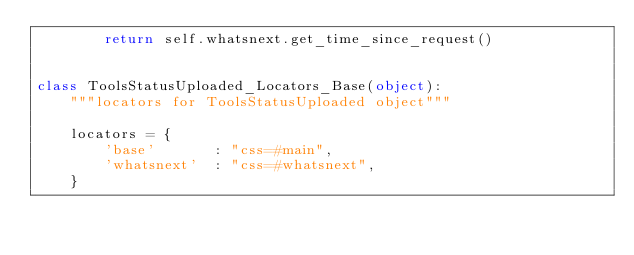Convert code to text. <code><loc_0><loc_0><loc_500><loc_500><_Python_>        return self.whatsnext.get_time_since_request()


class ToolsStatusUploaded_Locators_Base(object):
    """locators for ToolsStatusUploaded object"""

    locators = {
        'base'       : "css=#main",
        'whatsnext'  : "css=#whatsnext",
    }
</code> 